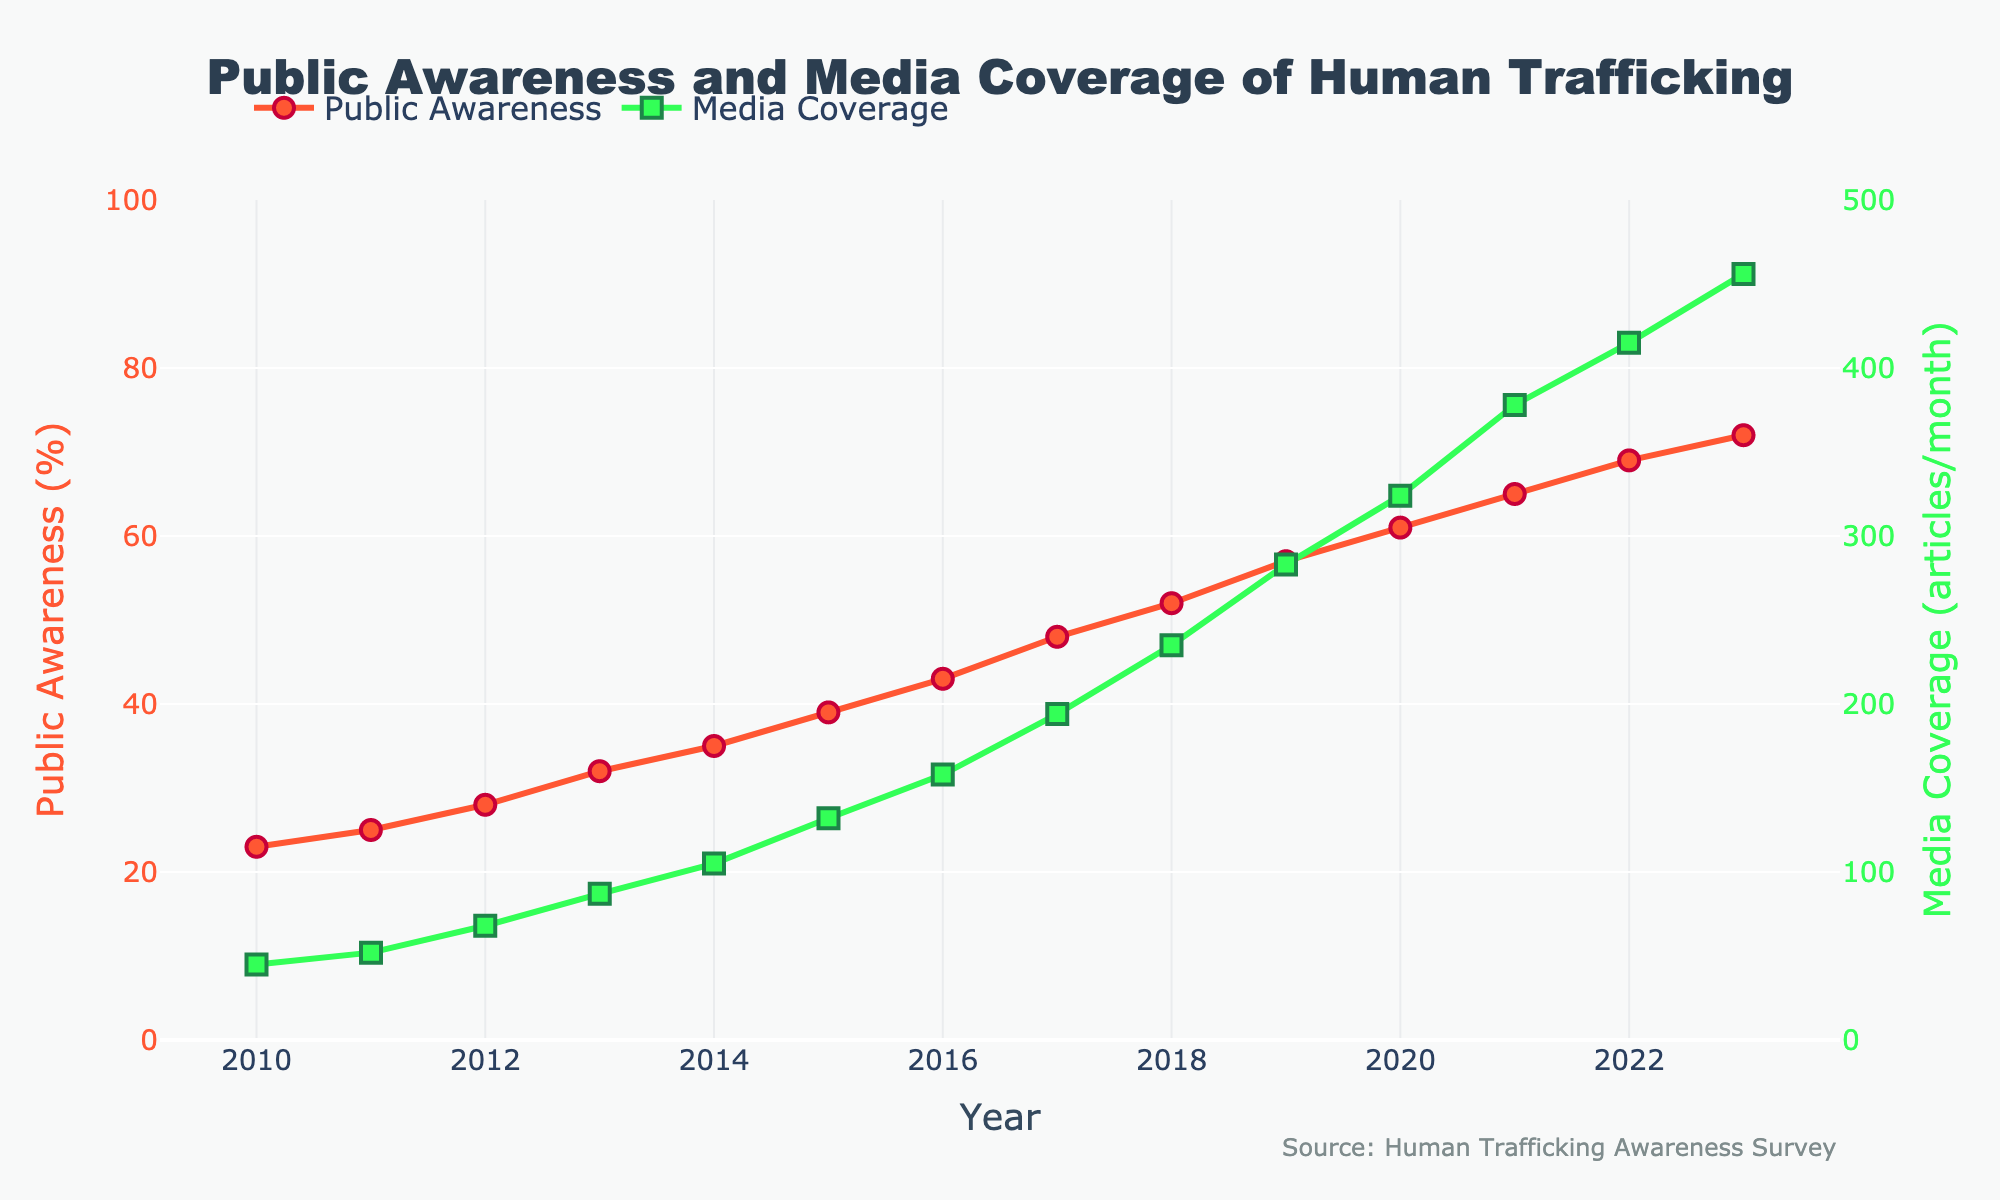What trend can be observed in public awareness of human trafficking over the years? From 2010 to 2023, the public awareness of human trafficking increased steadily each year. The data points show a consistent upward trend.
Answer: Increasing trend In which year did media coverage exceed 200 articles per month? By looking at the graph's media coverage part (green line with square markers), it can be seen that media coverage surpasses 200 articles per month in 2018.
Answer: 2018 Compare the rate of increase in public awareness between 2010-2014 and 2019-2023. Which period had a higher rate of increase? Calculate the increase for each period. From 2010 to 2014, awareness went from 23% to 35%, an increase of 12 percentage points over 4 years (3 points/year). From 2019 to 2023, it went from 57% to 72%, an increase of 15 percentage points over 4 years (3.75 points/year). The second period has a higher rate of increase.
Answer: 2019-2023 What was the difference in media coverage between the years 2014 and 2016? Media coverage in 2014 was 105 articles/month and in 2016 it was 158 articles/month. The difference is 158 - 105 which equals 53 articles/month.
Answer: 53 In which year did public awareness first reach or exceed 50%? The figure shows that in 2018 public awareness reached 52%, marking the first year it exceeded 50%.
Answer: 2018 What is the percentage increase in public awareness from 2010 to 2023? The initial awareness in 2010 was 23%, and by 2023 it was 72%. The percentage increase is calculated as ((72 - 23) / 23) * 100 = 213%.
Answer: 213% Which year showed the largest increase in media coverage compared to the previous year? Look at the media coverage values year over year. The largest increase appears between 2020 (324 articles/month) and 2021 (378 articles/month), which is 378 - 324 = 54 articles/month.
Answer: 2021 What was the average media coverage per month for the years 2010 to 2013 inclusive? Media coverage values for the years 2010 to 2013 are 45, 52, 68, and 87 articles/month, respectively. The average is calculated as (45 + 52 + 68 + 87) / 4 = 63 articles/month.
Answer: 63 